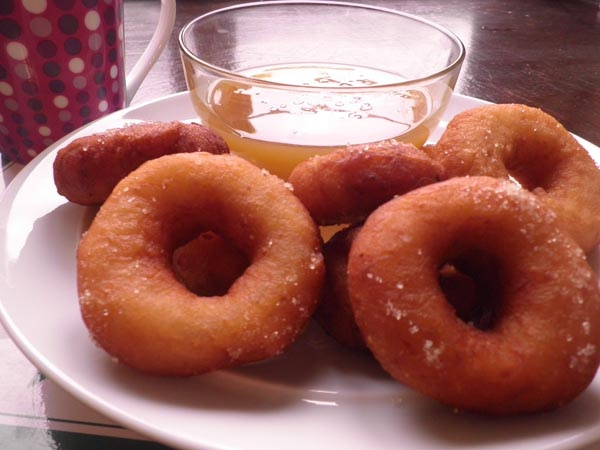Describe the objects in this image and their specific colors. I can see donut in black, maroon, and brown tones, donut in black, maroon, brown, and salmon tones, bowl in black, white, lightpink, brown, and salmon tones, dining table in black, maroon, lavender, brown, and darkgray tones, and cup in black, maroon, brown, and purple tones in this image. 